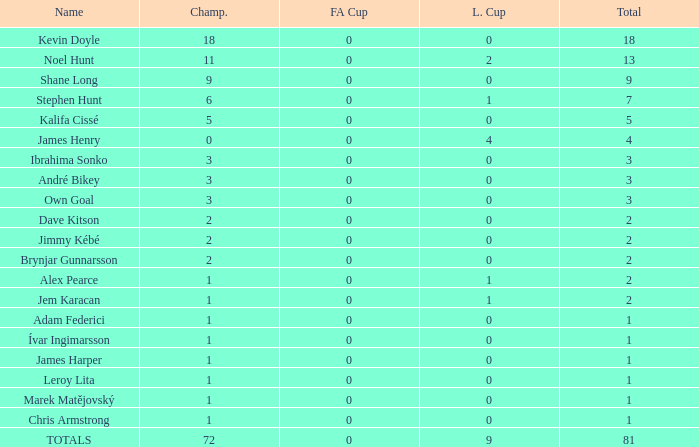What is the total championships that the league cup is less than 0? None. 